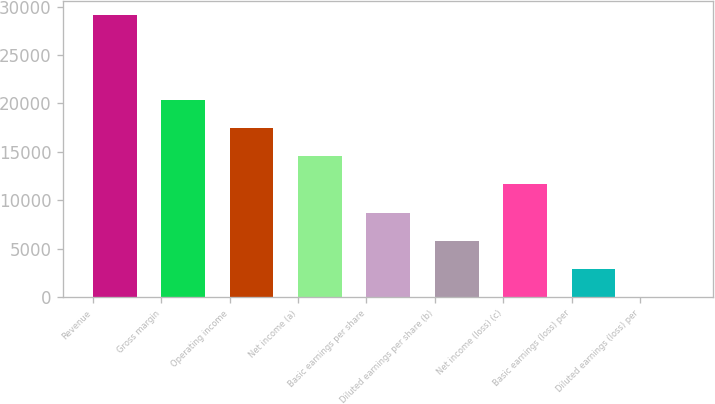<chart> <loc_0><loc_0><loc_500><loc_500><bar_chart><fcel>Revenue<fcel>Gross margin<fcel>Operating income<fcel>Net income (a)<fcel>Basic earnings per share<fcel>Diluted earnings per share (b)<fcel>Net income (loss) (c)<fcel>Basic earnings (loss) per<fcel>Diluted earnings (loss) per<nl><fcel>29084<fcel>20359.1<fcel>17450.8<fcel>14542.4<fcel>8725.8<fcel>5817.48<fcel>11634.1<fcel>2909.16<fcel>0.84<nl></chart> 